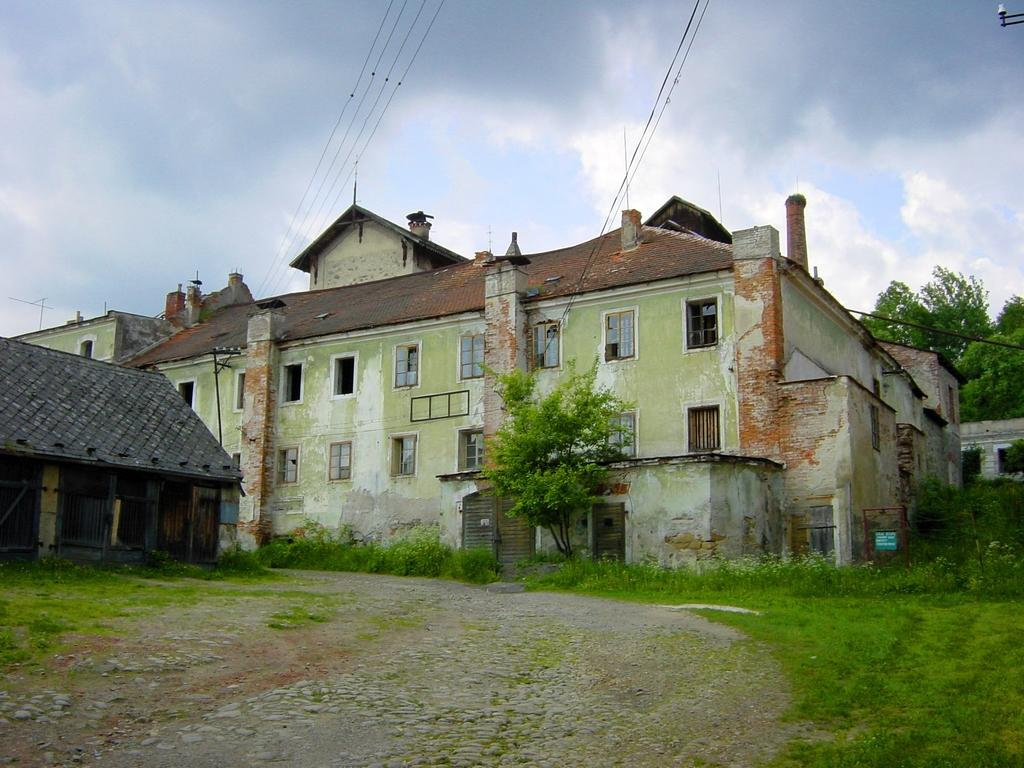What type of structures can be seen in the image? There are buildings in the image. What type of vegetation is present in the image? There is grass and trees in the image. What is visible at the top of the image? The sky is visible at the top of the image. Where is the mailbox located in the image? There is no mailbox present in the image. What type of dirt can be seen in the image? There is no dirt present in the image; it features buildings, grass, trees, and the sky. 